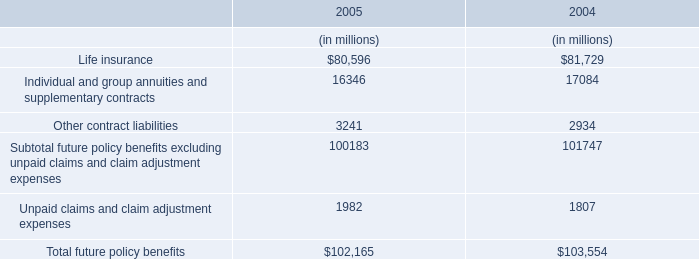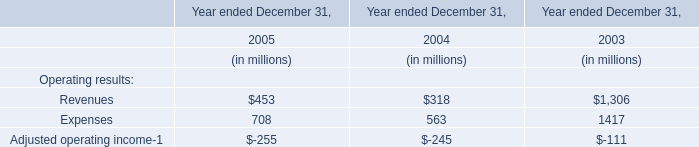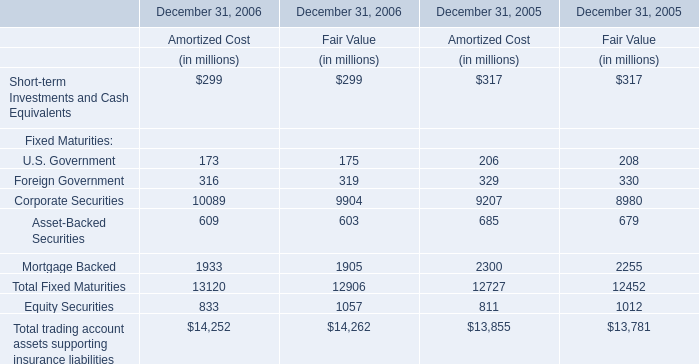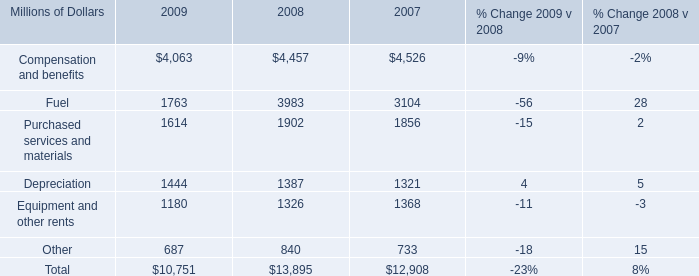What is the percentage of Corporate Securities for Fair Value in relation to the total in 2006? 
Computations: (9904 / 14262)
Answer: 0.69443. 